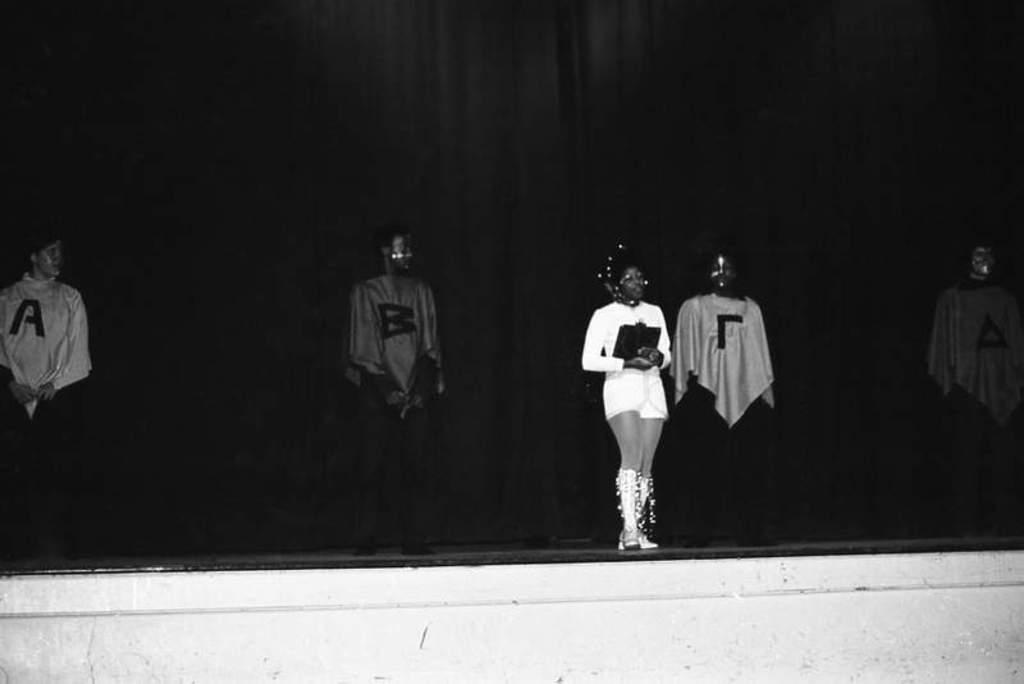What is happening in the foreground of the image? There are persons standing on the stage in the foreground of the image. What can be seen in the background of the image? There is a black curtain in the background of the image. What type of comb is being used by the person on the stage in the image? There is no comb visible in the image. What time is it according to the watch on the stage in the image? There is no watch visible in the image. 